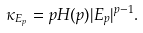Convert formula to latex. <formula><loc_0><loc_0><loc_500><loc_500>\kappa _ { E _ { p } } = p H ( p ) | E _ { p } | ^ { p - 1 } .</formula> 